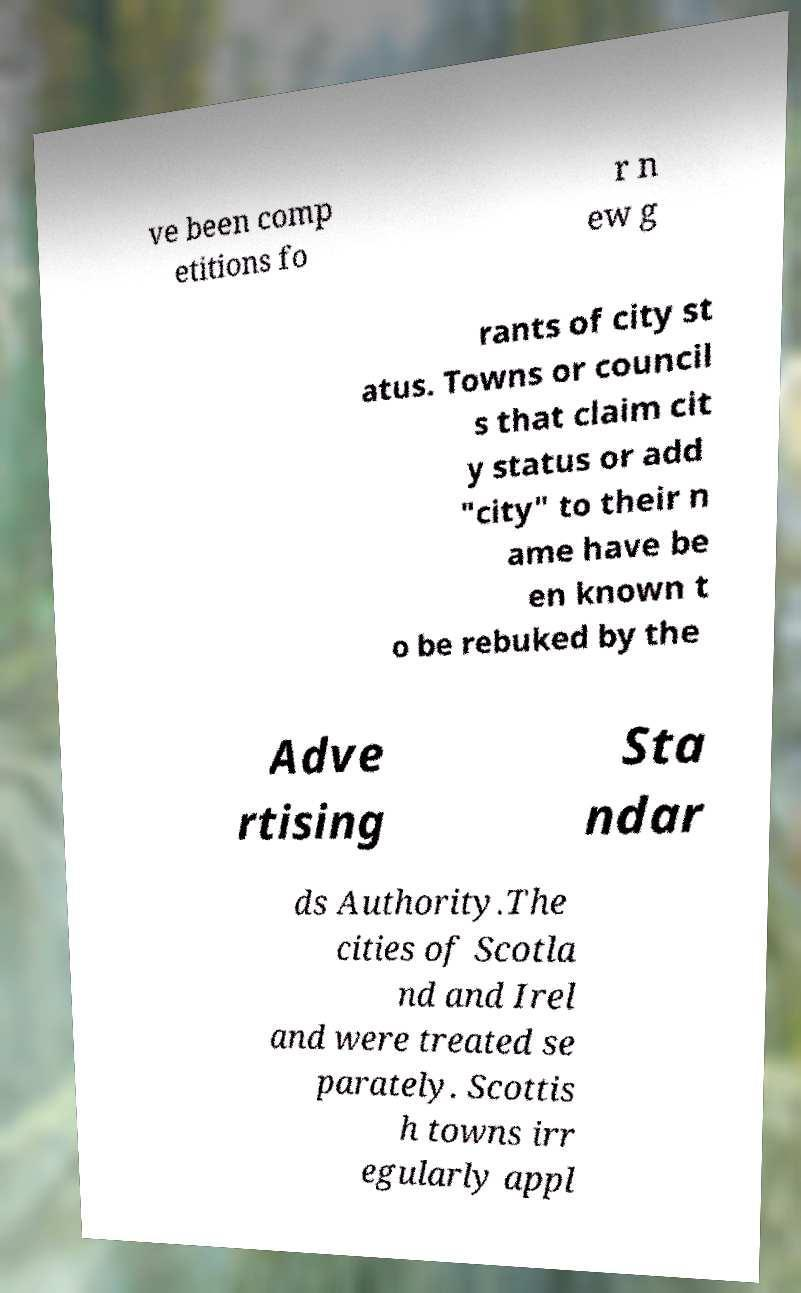What messages or text are displayed in this image? I need them in a readable, typed format. ve been comp etitions fo r n ew g rants of city st atus. Towns or council s that claim cit y status or add "city" to their n ame have be en known t o be rebuked by the Adve rtising Sta ndar ds Authority.The cities of Scotla nd and Irel and were treated se parately. Scottis h towns irr egularly appl 